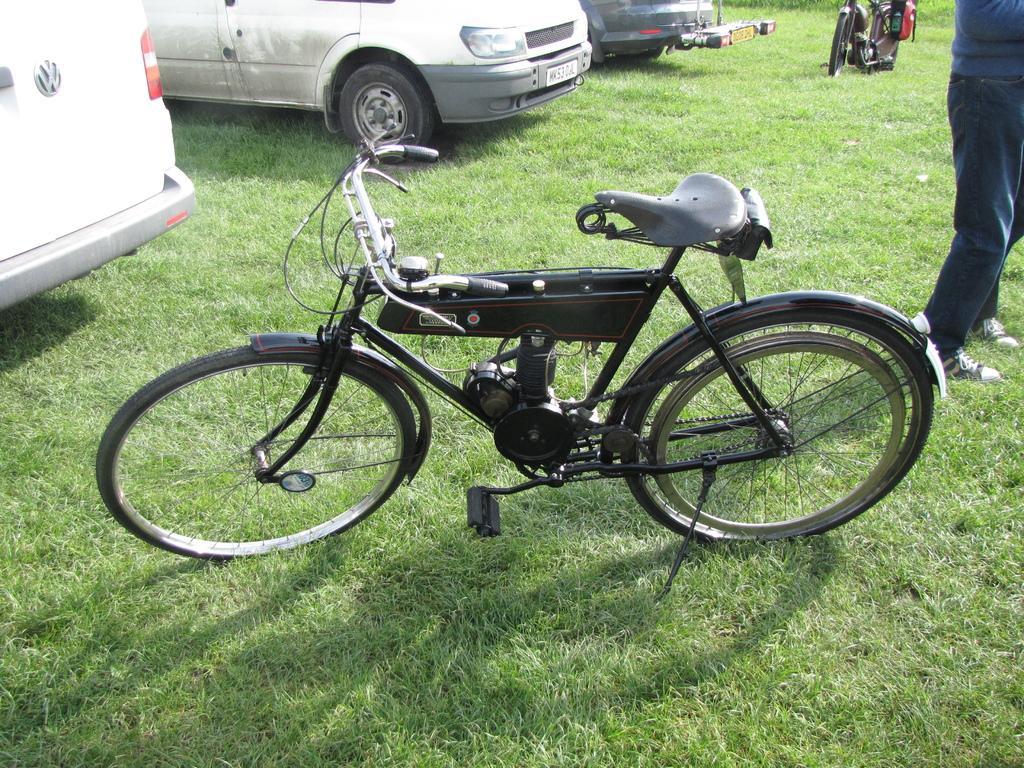Can you describe this image briefly? In this picture we can see vehicles and a person is standing on the right side of the picture. At the bottom portion of the picture we can see the green grass. And there is a bicycle. 